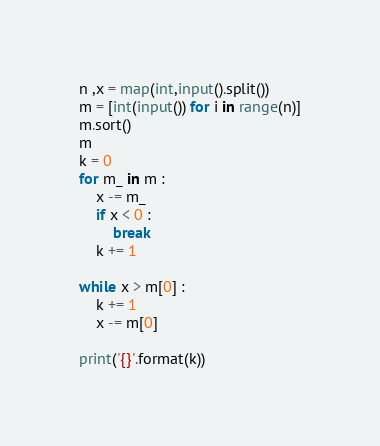<code> <loc_0><loc_0><loc_500><loc_500><_Python_>n ,x = map(int,input().split())
m = [int(input()) for i in range(n)]
m.sort()
m
k = 0
for m_ in m : 
    x -= m_
    if x < 0 :
        break
    k += 1

while x > m[0] :
    k += 1
    x -= m[0]
    
print('{}'.format(k))
</code> 